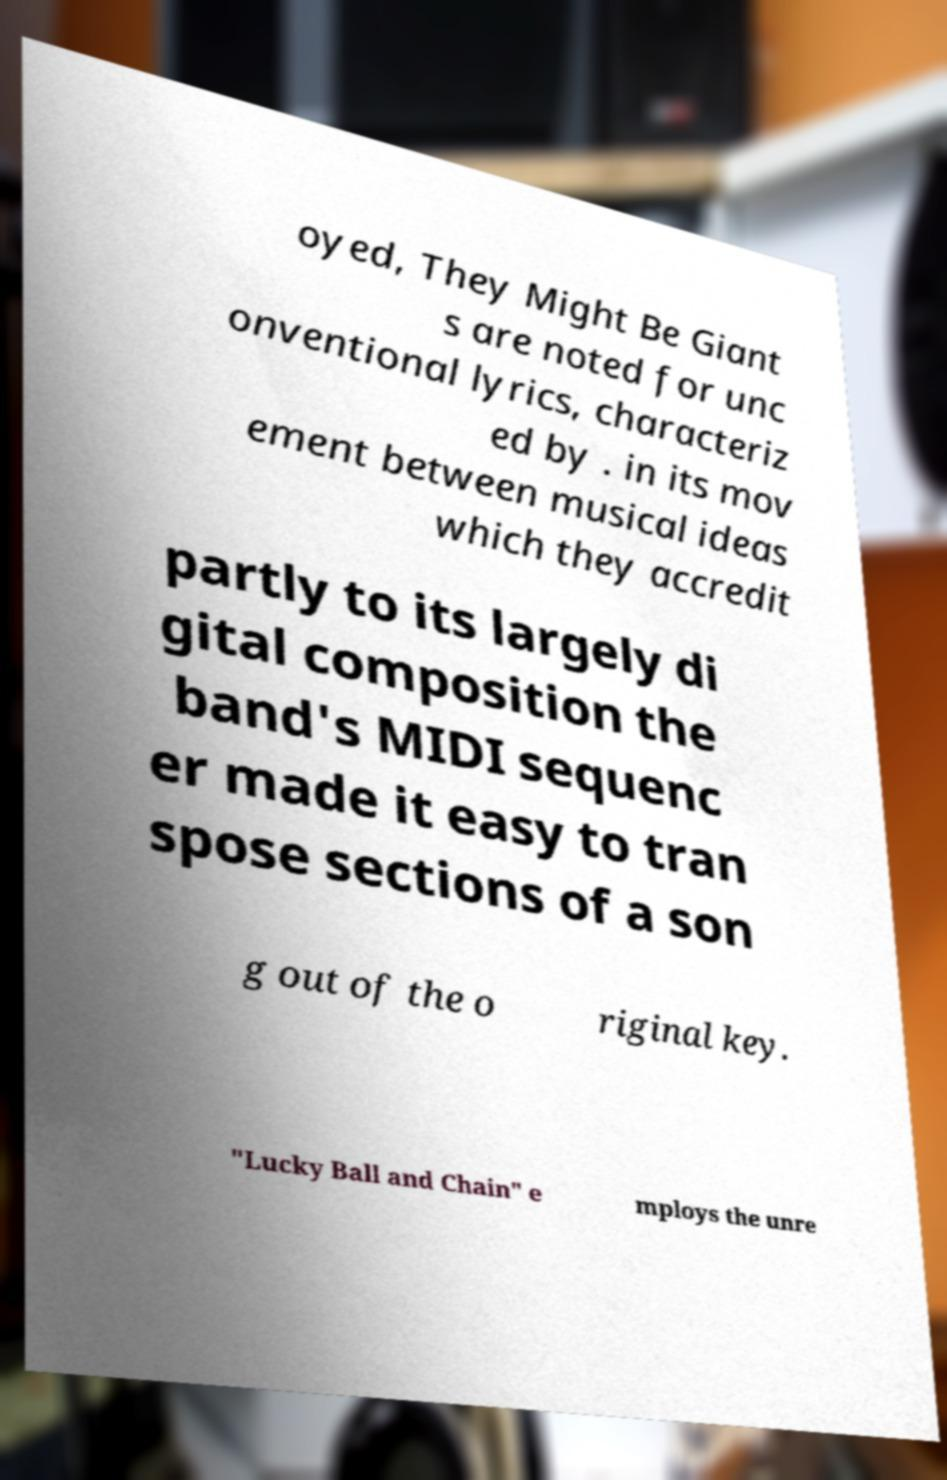For documentation purposes, I need the text within this image transcribed. Could you provide that? oyed, They Might Be Giant s are noted for unc onventional lyrics, characteriz ed by . in its mov ement between musical ideas which they accredit partly to its largely di gital composition the band's MIDI sequenc er made it easy to tran spose sections of a son g out of the o riginal key. "Lucky Ball and Chain" e mploys the unre 